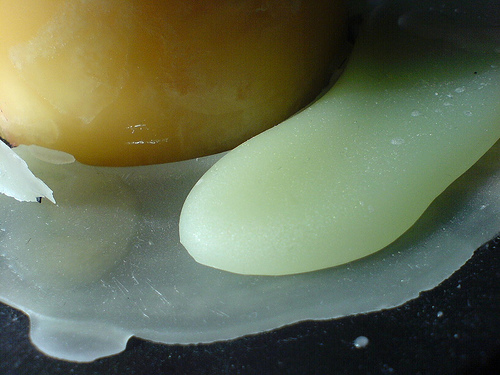<image>
Is there a egg in front of the bowl? No. The egg is not in front of the bowl. The spatial positioning shows a different relationship between these objects. 